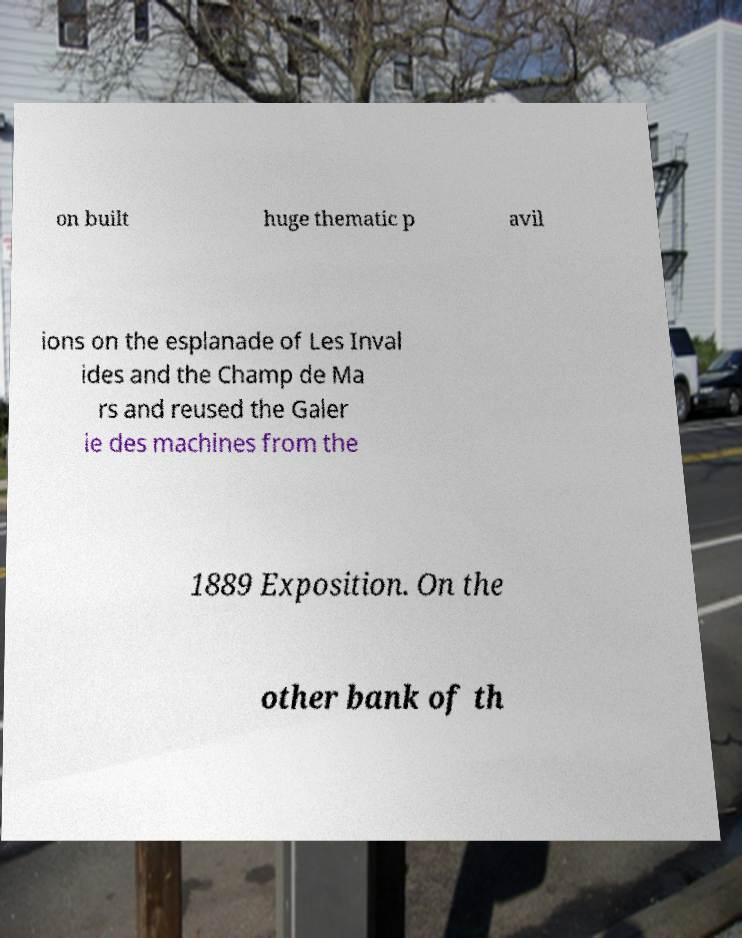What messages or text are displayed in this image? I need them in a readable, typed format. on built huge thematic p avil ions on the esplanade of Les Inval ides and the Champ de Ma rs and reused the Galer ie des machines from the 1889 Exposition. On the other bank of th 